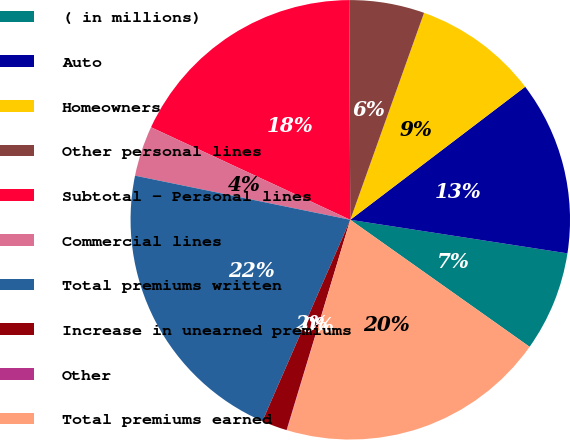<chart> <loc_0><loc_0><loc_500><loc_500><pie_chart><fcel>( in millions)<fcel>Auto<fcel>Homeowners<fcel>Other personal lines<fcel>Subtotal - Personal lines<fcel>Commercial lines<fcel>Total premiums written<fcel>Increase in unearned premiums<fcel>Other<fcel>Total premiums earned<nl><fcel>7.37%<fcel>12.79%<fcel>9.2%<fcel>5.53%<fcel>18.0%<fcel>3.7%<fcel>21.67%<fcel>1.87%<fcel>0.03%<fcel>19.84%<nl></chart> 